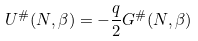<formula> <loc_0><loc_0><loc_500><loc_500>U ^ { \# } ( N , \beta ) = - \frac { q } { 2 } G ^ { \# } ( N , \beta )</formula> 